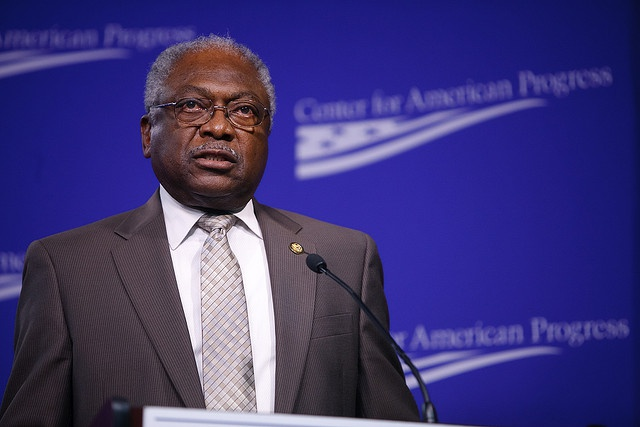Describe the objects in this image and their specific colors. I can see people in navy, black, gray, and lavender tones and tie in navy, lightgray, and darkgray tones in this image. 